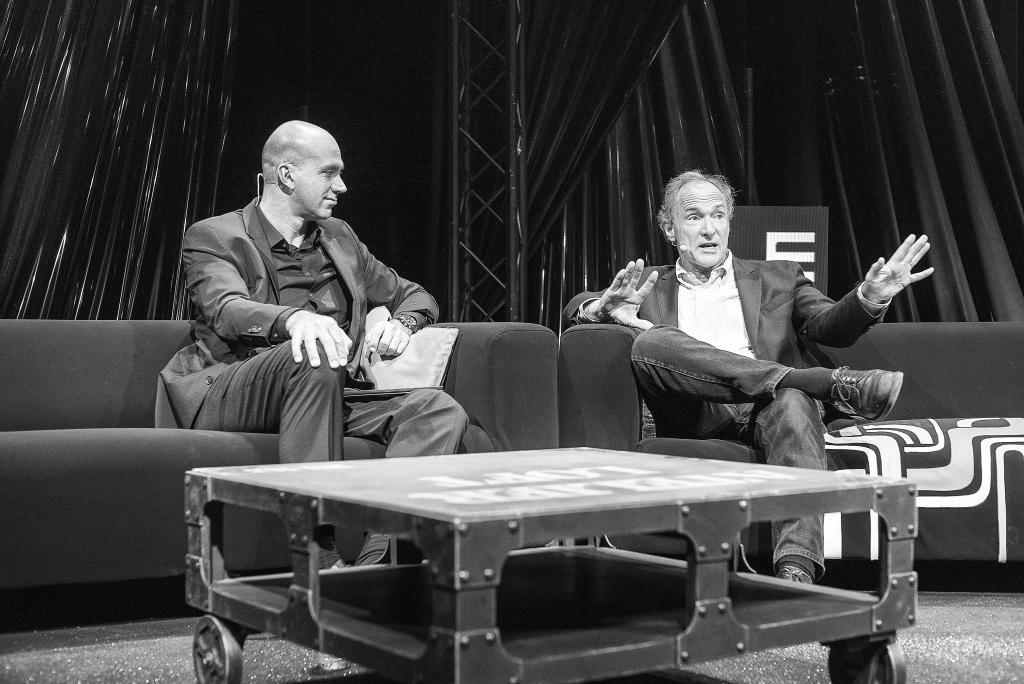How many people are in the image? There are two men in the image. What are the men doing in the image? The men are sitting on a sofa and talking on a microphone. What is in front of the men? There is a table in front of the men. What can be seen in the background of the image? There is a pillar and curtains in the background of the image. What type of animal is protesting in the image? There is no animal or protest present in the image. 